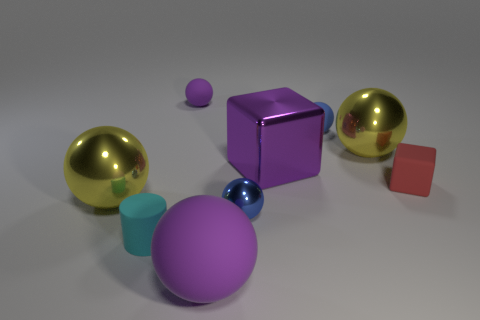Subtract all yellow balls. How many balls are left? 4 Subtract all large purple balls. How many balls are left? 5 Subtract all red balls. Subtract all yellow cylinders. How many balls are left? 6 Add 1 big purple objects. How many objects exist? 10 Subtract all blocks. How many objects are left? 7 Add 4 large purple rubber spheres. How many large purple rubber spheres exist? 5 Subtract 2 yellow spheres. How many objects are left? 7 Subtract all tiny metallic objects. Subtract all purple matte things. How many objects are left? 6 Add 5 blue rubber things. How many blue rubber things are left? 6 